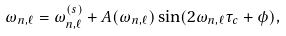<formula> <loc_0><loc_0><loc_500><loc_500>\omega _ { n , \ell } = \omega ^ { ( s ) } _ { n , \ell } + A ( \omega _ { n , \ell } ) \sin ( 2 \omega _ { n , \ell } \tau _ { c } + \phi ) ,</formula> 